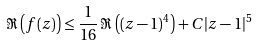<formula> <loc_0><loc_0><loc_500><loc_500>\Re \left ( f ( z ) \right ) \leq \frac { 1 } { 1 6 } \, \Re \left ( ( z - 1 ) ^ { 4 } \right ) + C | z - 1 | ^ { 5 }</formula> 